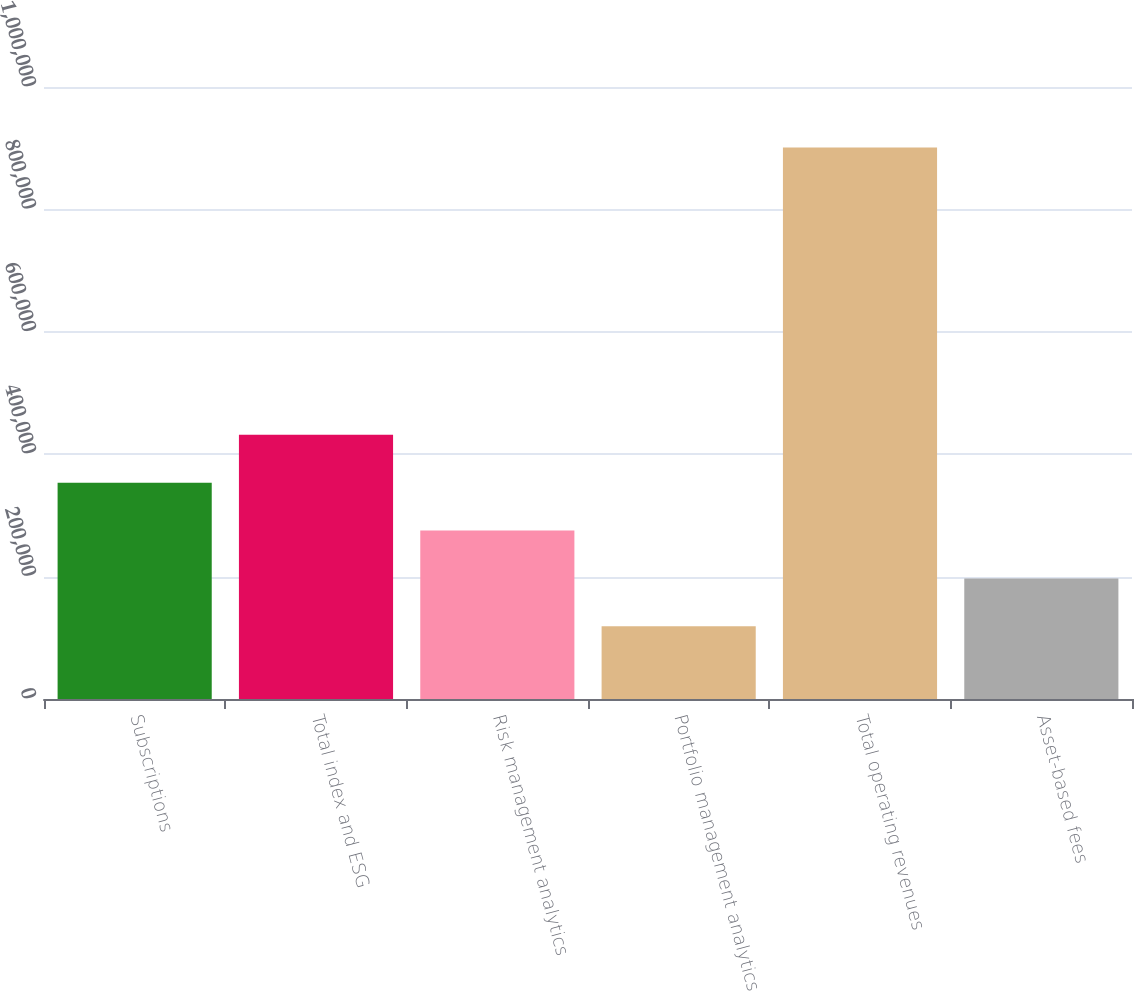Convert chart to OTSL. <chart><loc_0><loc_0><loc_500><loc_500><bar_chart><fcel>Subscriptions<fcel>Total index and ESG<fcel>Risk management analytics<fcel>Portfolio management analytics<fcel>Total operating revenues<fcel>Asset-based fees<nl><fcel>353505<fcel>431710<fcel>275299<fcel>118889<fcel>900941<fcel>197094<nl></chart> 